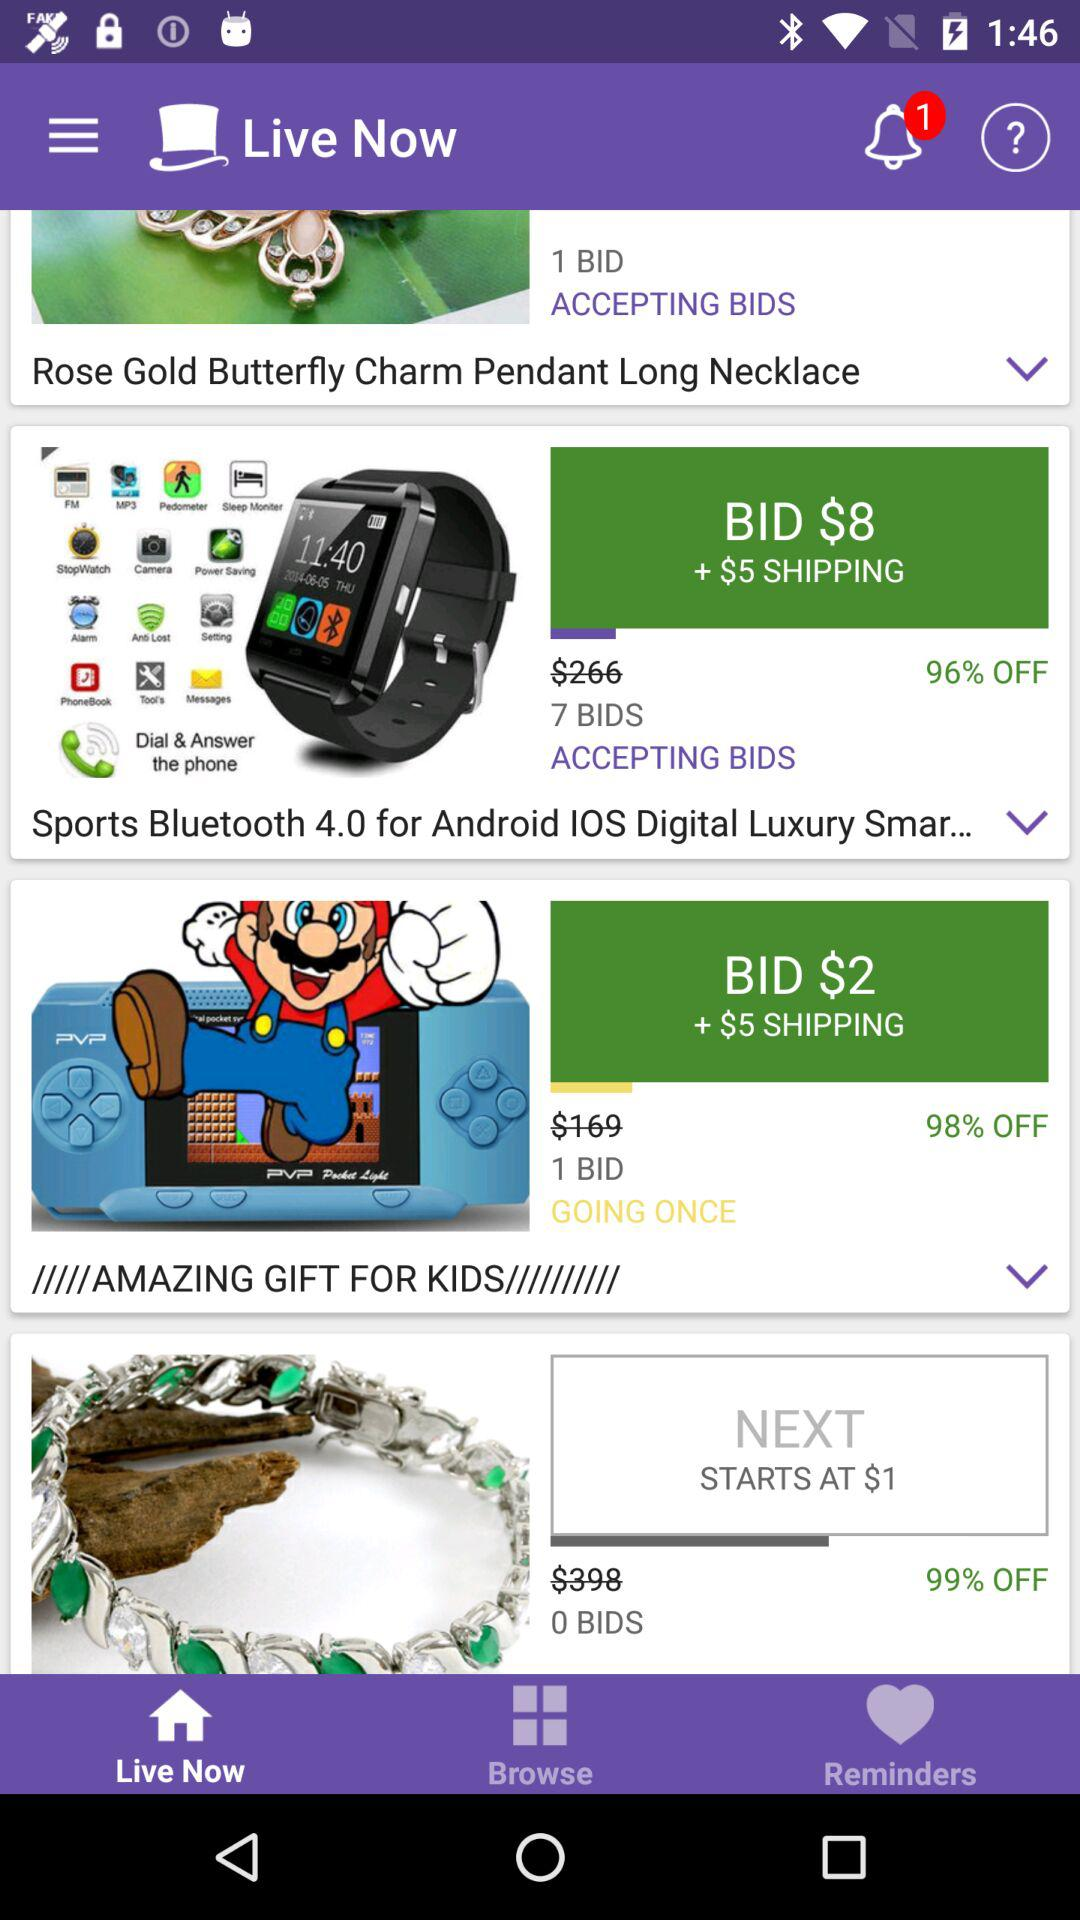What is the lowest price of an item?
Answer the question using a single word or phrase. $1 